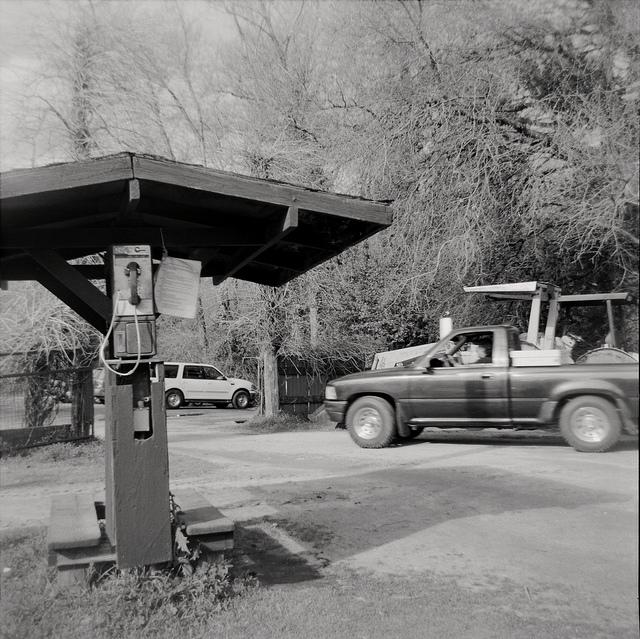The item under the roof can best be described as what? Please explain your reasoning. outdated. The item is above ground. it is a payphone, not a cow. 